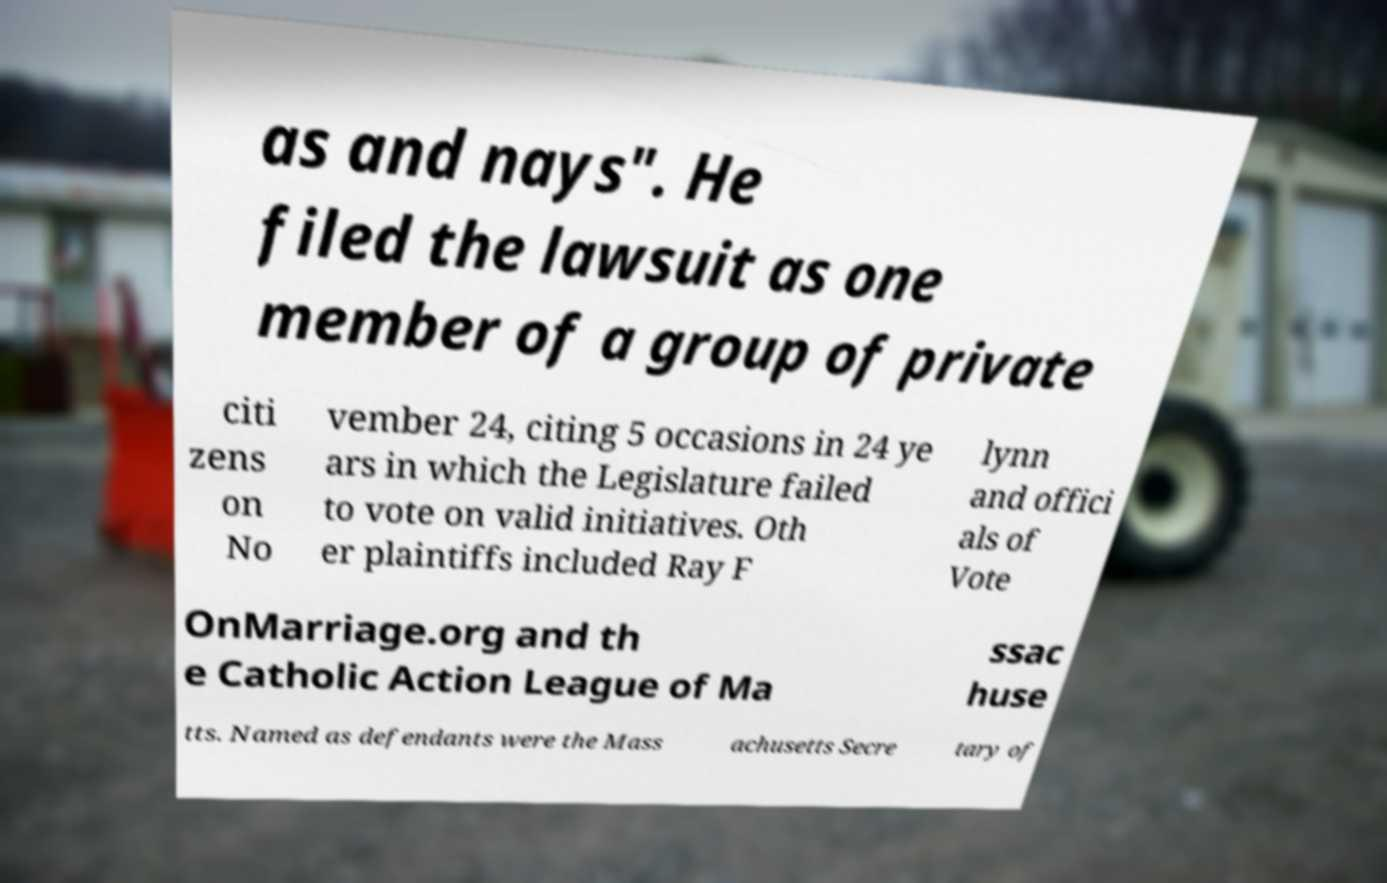Can you accurately transcribe the text from the provided image for me? as and nays". He filed the lawsuit as one member of a group of private citi zens on No vember 24, citing 5 occasions in 24 ye ars in which the Legislature failed to vote on valid initiatives. Oth er plaintiffs included Ray F lynn and offici als of Vote OnMarriage.org and th e Catholic Action League of Ma ssac huse tts. Named as defendants were the Mass achusetts Secre tary of 